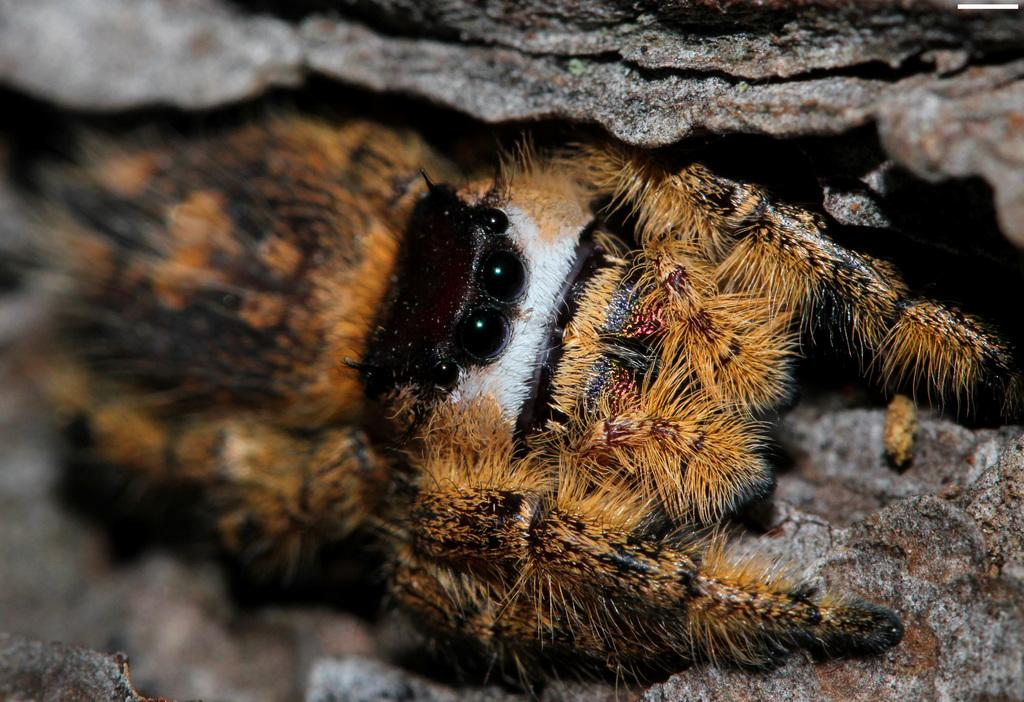What type of creature is present in the image? There is an animal in the image. Can you describe the color of the animal? The animal is brown in color. What other object can be seen in the image? There is a stone in the image. How much profit did the son make from the visitor in the image? There is no mention of a son, visitor, or profit in the image, as it only features an animal and a stone. 